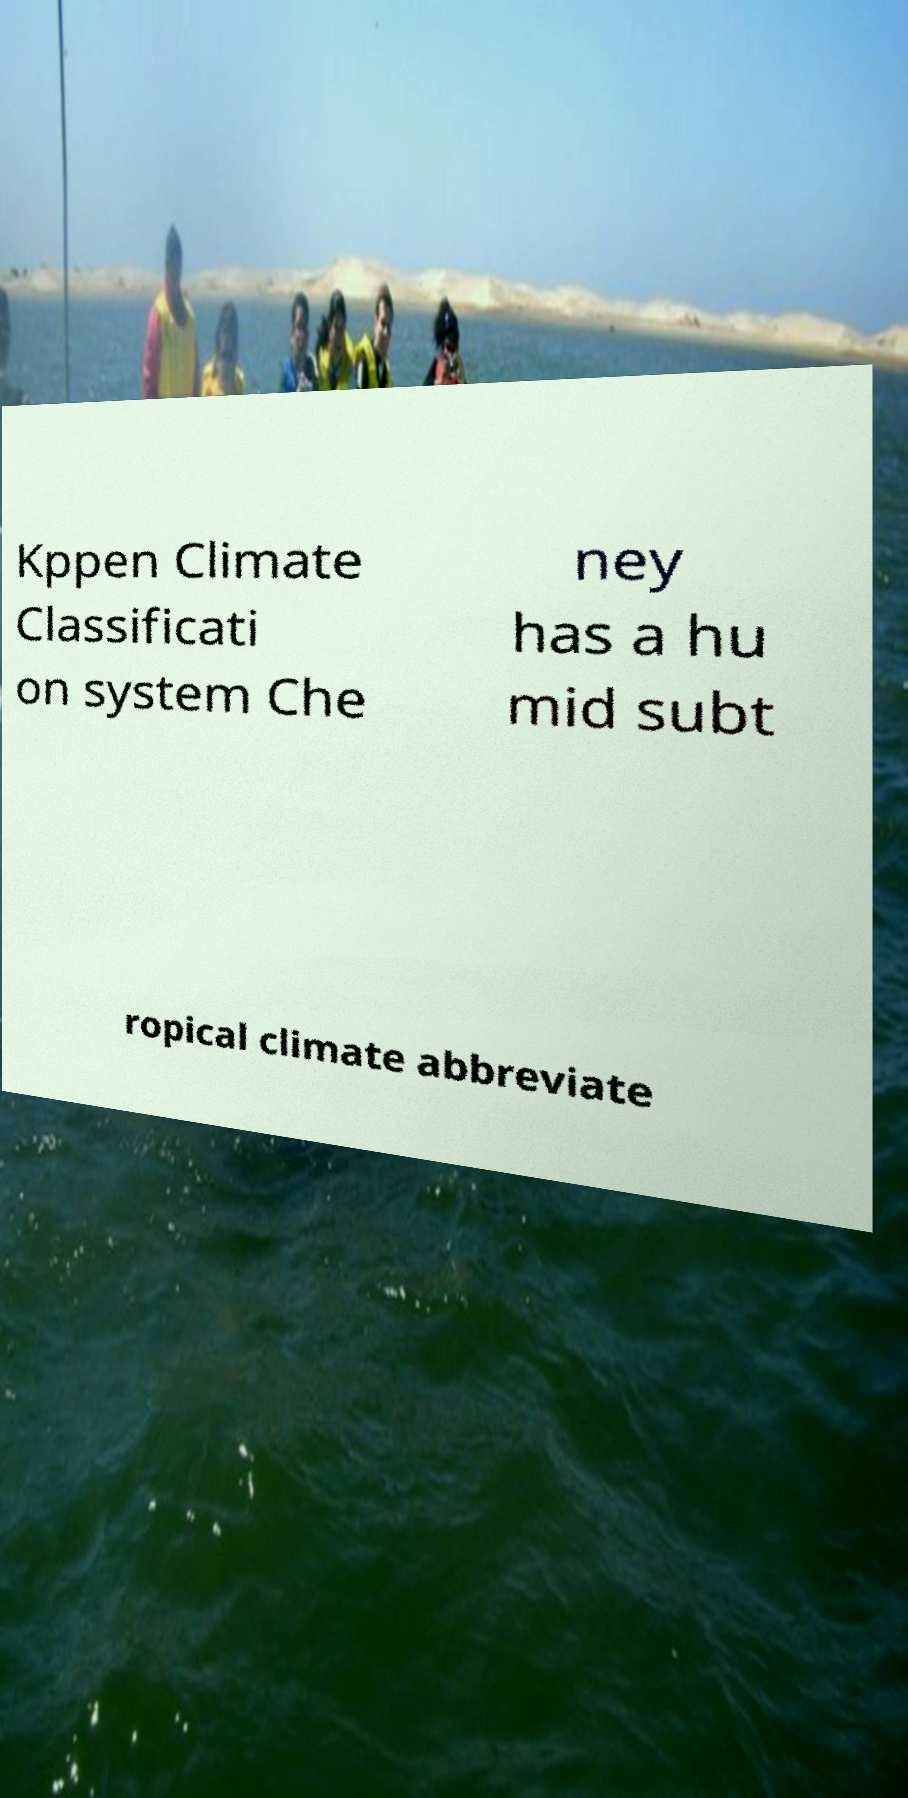Please identify and transcribe the text found in this image. Kppen Climate Classificati on system Che ney has a hu mid subt ropical climate abbreviate 